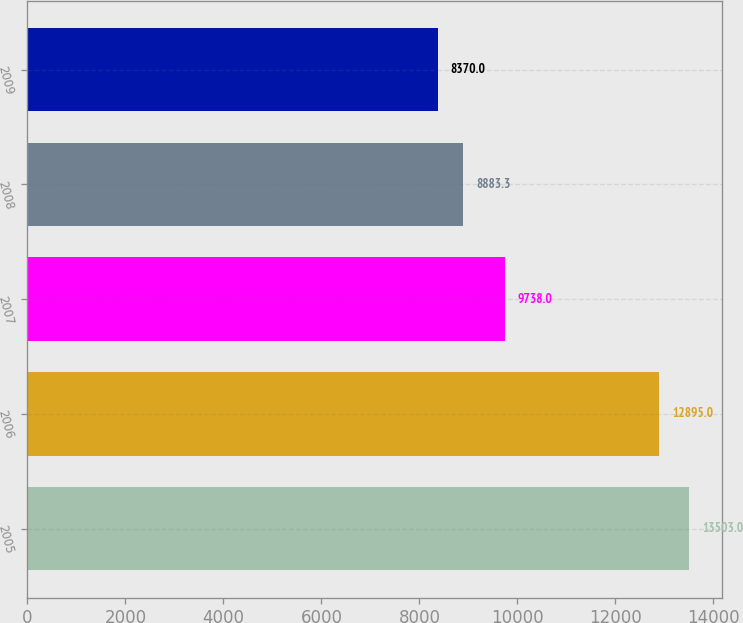Convert chart. <chart><loc_0><loc_0><loc_500><loc_500><bar_chart><fcel>2005<fcel>2006<fcel>2007<fcel>2008<fcel>2009<nl><fcel>13503<fcel>12895<fcel>9738<fcel>8883.3<fcel>8370<nl></chart> 